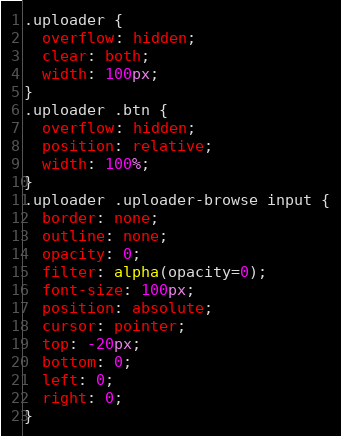Convert code to text. <code><loc_0><loc_0><loc_500><loc_500><_CSS_>.uploader {
  overflow: hidden;
  clear: both;
  width: 100px;
}
.uploader .btn {
  overflow: hidden;
  position: relative;
  width: 100%;
}
.uploader .uploader-browse input {
  border: none;
  outline: none;
  opacity: 0;
  filter: alpha(opacity=0);
  font-size: 100px;
  position: absolute;
  cursor: pointer;
  top: -20px;
  bottom: 0;
  left: 0;
  right: 0;
}</code> 